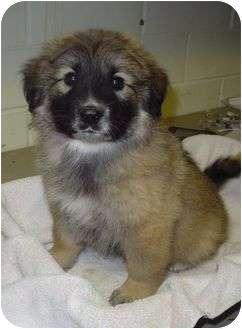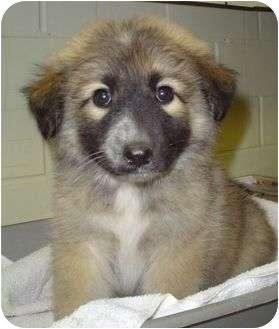The first image is the image on the left, the second image is the image on the right. Evaluate the accuracy of this statement regarding the images: "There are two animals in one of the images.". Is it true? Answer yes or no. No. 